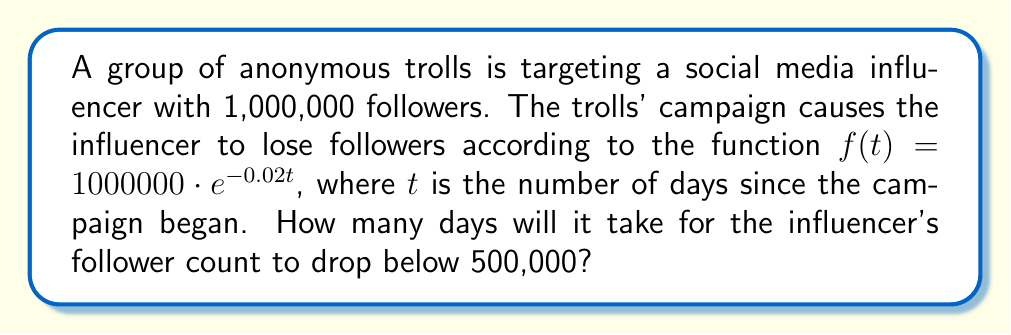Give your solution to this math problem. To solve this problem, we need to use the exponential decay function given and solve for $t$ when $f(t) = 500000$.

1) We start with the equation:
   $f(t) = 1000000 \cdot e^{-0.02t}$

2) We want to find $t$ when $f(t) = 500000$, so we set up the equation:
   $500000 = 1000000 \cdot e^{-0.02t}$

3) Divide both sides by 1000000:
   $\frac{1}{2} = e^{-0.02t}$

4) Take the natural logarithm of both sides:
   $\ln(\frac{1}{2}) = \ln(e^{-0.02t})$

5) Simplify the right side using the properties of logarithms:
   $\ln(\frac{1}{2}) = -0.02t$

6) Solve for $t$:
   $t = \frac{\ln(\frac{1}{2})}{-0.02}$

7) Calculate the value:
   $t = \frac{-0.693147...}{-0.02} \approx 34.66$ days

8) Since we're looking for the number of whole days, we round up to the next integer.
Answer: It will take 35 days for the influencer's follower count to drop below 500,000. 